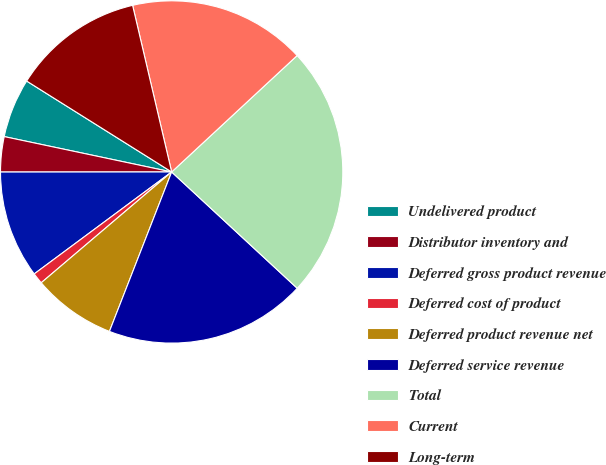Convert chart. <chart><loc_0><loc_0><loc_500><loc_500><pie_chart><fcel>Undelivered product<fcel>Distributor inventory and<fcel>Deferred gross product revenue<fcel>Deferred cost of product<fcel>Deferred product revenue net<fcel>Deferred service revenue<fcel>Total<fcel>Current<fcel>Long-term<nl><fcel>5.6%<fcel>3.32%<fcel>10.15%<fcel>1.05%<fcel>7.87%<fcel>19.03%<fcel>23.79%<fcel>16.76%<fcel>12.42%<nl></chart> 